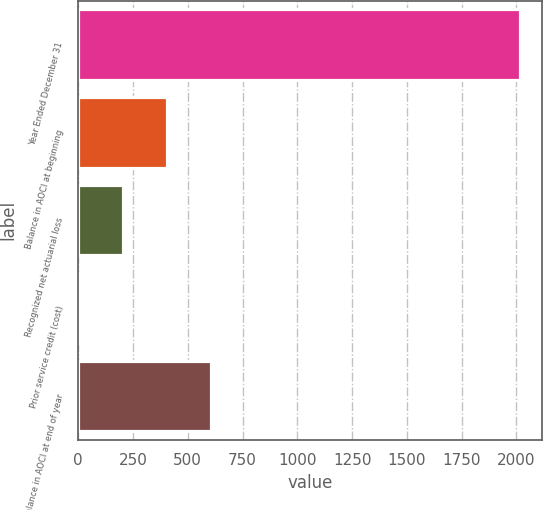Convert chart. <chart><loc_0><loc_0><loc_500><loc_500><bar_chart><fcel>Year Ended December 31<fcel>Balance in AOCI at beginning<fcel>Recognized net actuarial loss<fcel>Prior service credit (cost)<fcel>Balance in AOCI at end of year<nl><fcel>2016<fcel>406.4<fcel>205.2<fcel>4<fcel>607.6<nl></chart> 